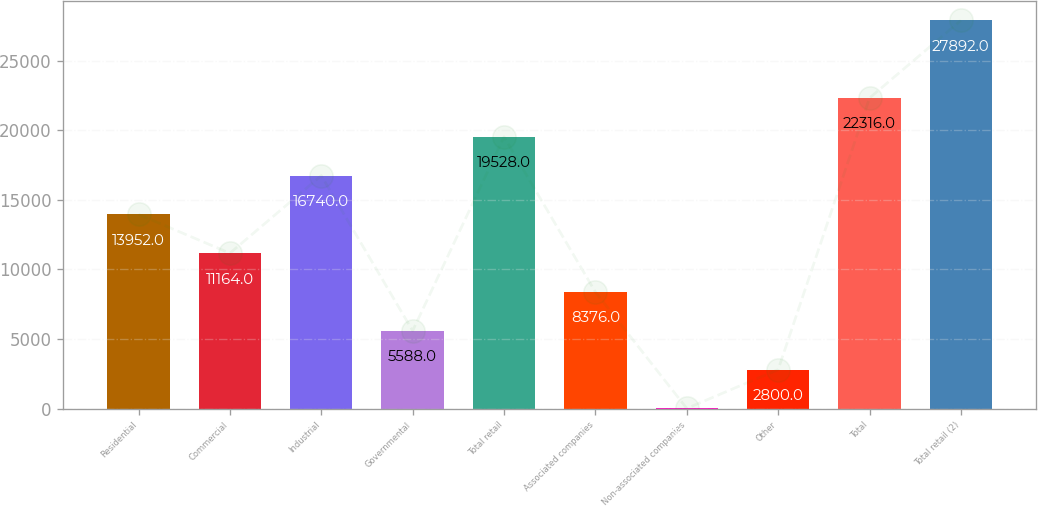Convert chart to OTSL. <chart><loc_0><loc_0><loc_500><loc_500><bar_chart><fcel>Residential<fcel>Commercial<fcel>Industrial<fcel>Governmental<fcel>Total retail<fcel>Associated companies<fcel>Non-associated companies<fcel>Other<fcel>Total<fcel>Total retail (2)<nl><fcel>13952<fcel>11164<fcel>16740<fcel>5588<fcel>19528<fcel>8376<fcel>12<fcel>2800<fcel>22316<fcel>27892<nl></chart> 